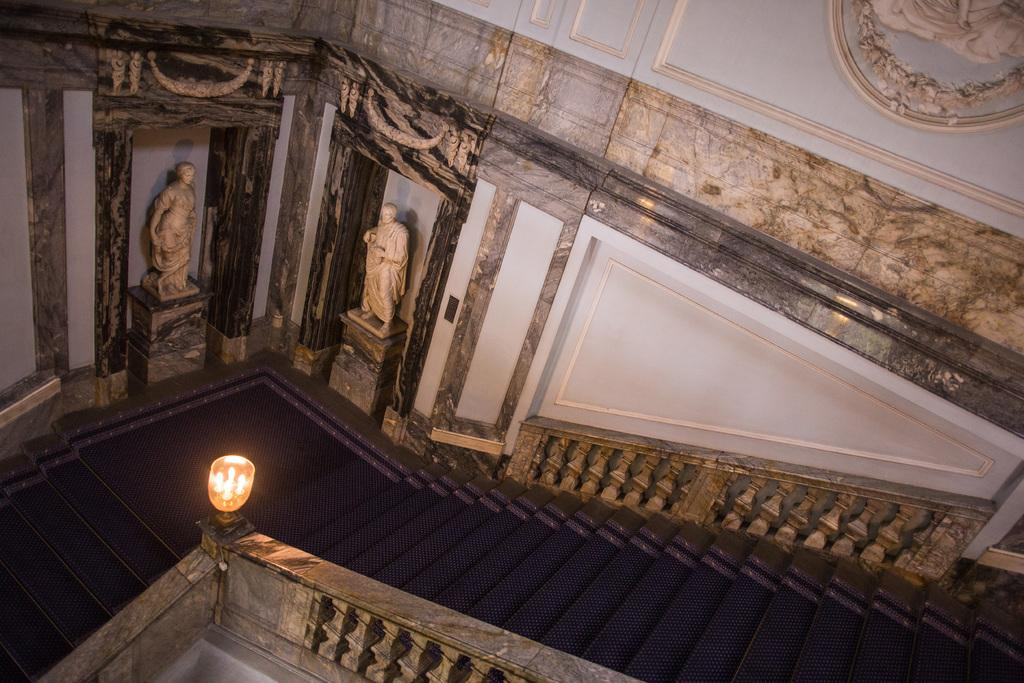What type of structure is present in the image? There are stairs in the image. What can be seen behind the stairs? There are sculptures behind the stairs. What is visible in the background of the image? There is a wall in the background of the image. Can you describe the lighting on the stairs? There is a light fixed on the railing of the stairs. How many bricks are used to construct the stairs in the image? There is no information about the construction of the stairs or the use of bricks in the image. Can you describe the girls playing near the stairs in the image? There are no girls present in the image; it only features stairs, sculptures, a wall, and a light on the railing. 